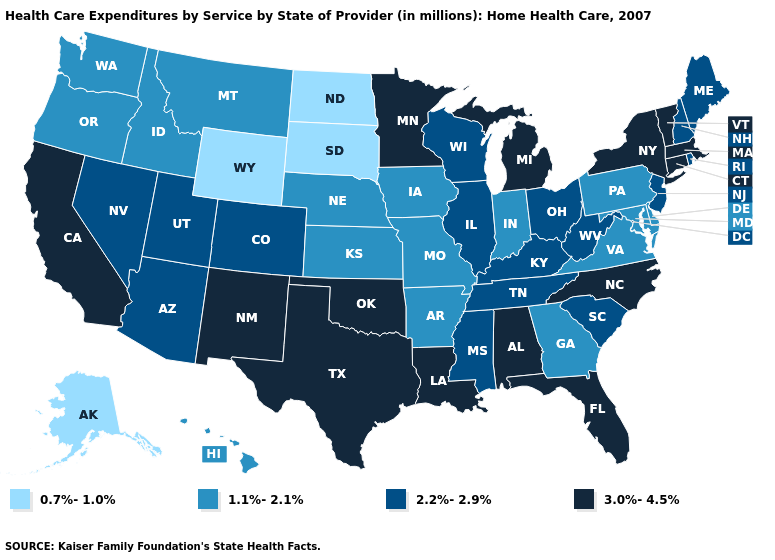Does Oklahoma have a lower value than California?
Quick response, please. No. Does the map have missing data?
Quick response, please. No. What is the value of Washington?
Write a very short answer. 1.1%-2.1%. Name the states that have a value in the range 3.0%-4.5%?
Write a very short answer. Alabama, California, Connecticut, Florida, Louisiana, Massachusetts, Michigan, Minnesota, New Mexico, New York, North Carolina, Oklahoma, Texas, Vermont. Does Florida have the lowest value in the South?
Be succinct. No. What is the value of Connecticut?
Keep it brief. 3.0%-4.5%. Name the states that have a value in the range 3.0%-4.5%?
Write a very short answer. Alabama, California, Connecticut, Florida, Louisiana, Massachusetts, Michigan, Minnesota, New Mexico, New York, North Carolina, Oklahoma, Texas, Vermont. What is the value of Ohio?
Give a very brief answer. 2.2%-2.9%. What is the value of Michigan?
Give a very brief answer. 3.0%-4.5%. Among the states that border Arkansas , which have the highest value?
Concise answer only. Louisiana, Oklahoma, Texas. Does Texas have the highest value in the USA?
Concise answer only. Yes. Does the first symbol in the legend represent the smallest category?
Give a very brief answer. Yes. Does Pennsylvania have the lowest value in the Northeast?
Write a very short answer. Yes. Among the states that border Georgia , does South Carolina have the highest value?
Keep it brief. No. What is the lowest value in the USA?
Write a very short answer. 0.7%-1.0%. 